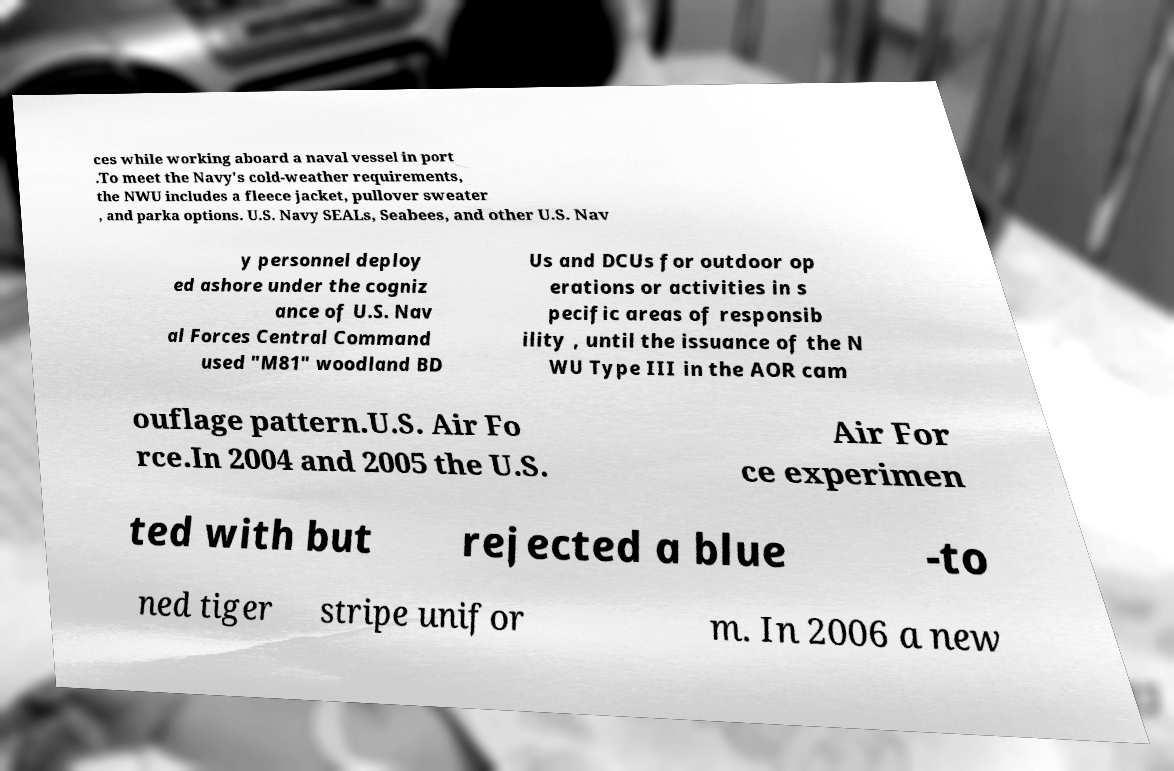Can you accurately transcribe the text from the provided image for me? ces while working aboard a naval vessel in port .To meet the Navy's cold-weather requirements, the NWU includes a fleece jacket, pullover sweater , and parka options. U.S. Navy SEALs, Seabees, and other U.S. Nav y personnel deploy ed ashore under the cogniz ance of U.S. Nav al Forces Central Command used "M81" woodland BD Us and DCUs for outdoor op erations or activities in s pecific areas of responsib ility , until the issuance of the N WU Type III in the AOR cam ouflage pattern.U.S. Air Fo rce.In 2004 and 2005 the U.S. Air For ce experimen ted with but rejected a blue -to ned tiger stripe unifor m. In 2006 a new 